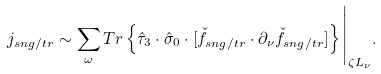Convert formula to latex. <formula><loc_0><loc_0><loc_500><loc_500>j _ { s n g / t r } \sim \sum _ { \omega } T r \left \{ \hat { \tau } _ { 3 } \cdot \hat { \sigma } _ { 0 } \cdot [ \check { f } _ { s n g / t r } \cdot \partial _ { \nu } \check { f } _ { s n g / t r } ] \right \} \Big | _ { \zeta L _ { \nu } } .</formula> 